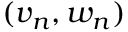Convert formula to latex. <formula><loc_0><loc_0><loc_500><loc_500>( v _ { n } , w _ { n } )</formula> 